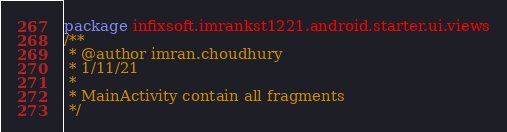<code> <loc_0><loc_0><loc_500><loc_500><_Kotlin_>package infixsoft.imrankst1221.android.starter.ui.views
/**
 * @author imran.choudhury
 * 1/11/21
 *
 * MainActivity contain all fragments
 */

</code> 